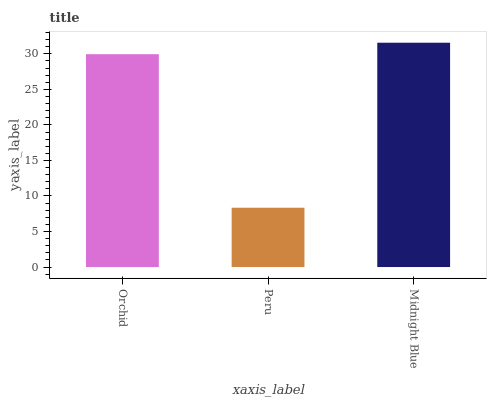Is Peru the minimum?
Answer yes or no. Yes. Is Midnight Blue the maximum?
Answer yes or no. Yes. Is Midnight Blue the minimum?
Answer yes or no. No. Is Peru the maximum?
Answer yes or no. No. Is Midnight Blue greater than Peru?
Answer yes or no. Yes. Is Peru less than Midnight Blue?
Answer yes or no. Yes. Is Peru greater than Midnight Blue?
Answer yes or no. No. Is Midnight Blue less than Peru?
Answer yes or no. No. Is Orchid the high median?
Answer yes or no. Yes. Is Orchid the low median?
Answer yes or no. Yes. Is Midnight Blue the high median?
Answer yes or no. No. Is Peru the low median?
Answer yes or no. No. 